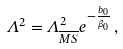Convert formula to latex. <formula><loc_0><loc_0><loc_500><loc_500>\Lambda ^ { 2 } = \Lambda _ { \overline { M S } } ^ { 2 } e ^ { - \frac { b _ { 0 } } { \beta _ { 0 } } } \, ,</formula> 